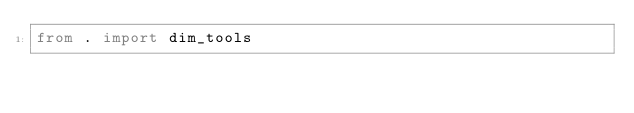Convert code to text. <code><loc_0><loc_0><loc_500><loc_500><_Python_>from . import dim_tools</code> 